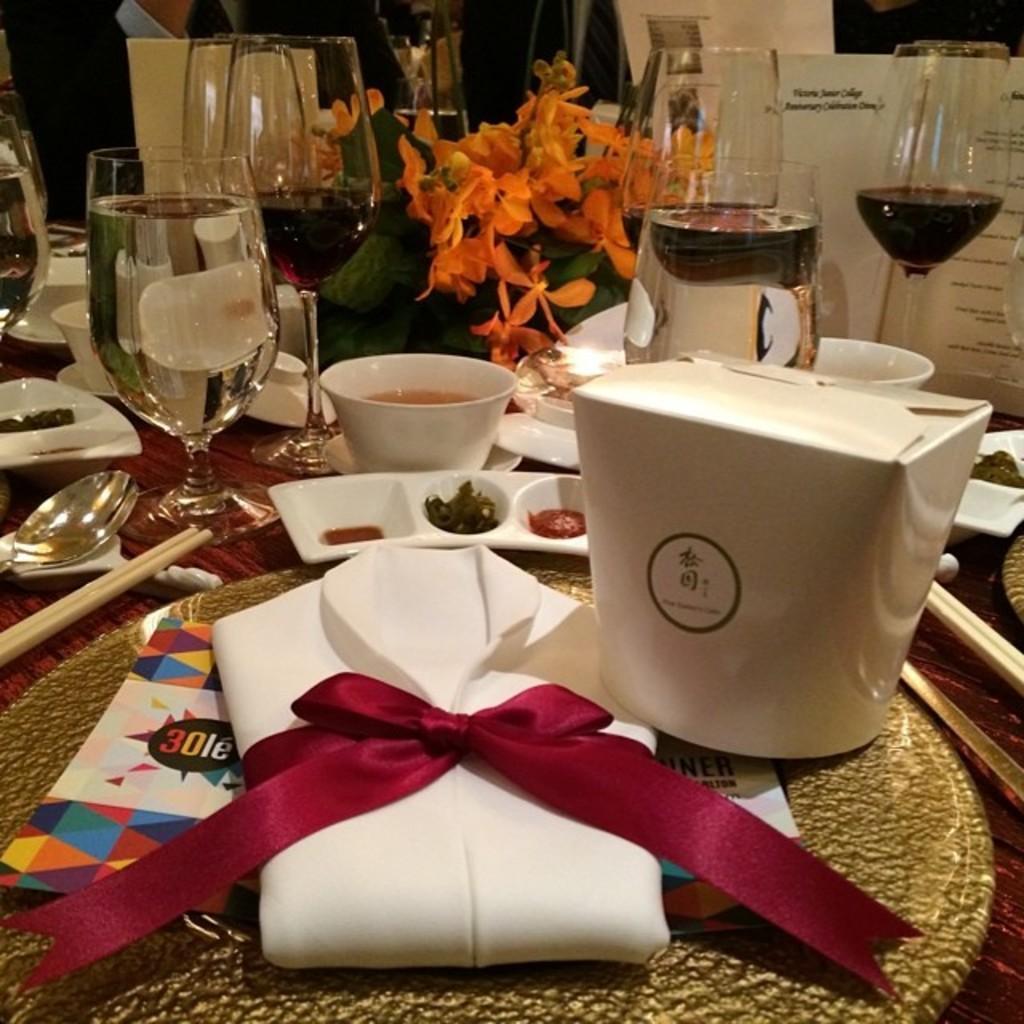Please provide a concise description of this image. In this picture we can see a tray, here we can see a box and cloth here, we can see a ribbon and some food there are some flowers here we can see some drinks which are in the glasses, in the background there is a person we can see a paper here. 